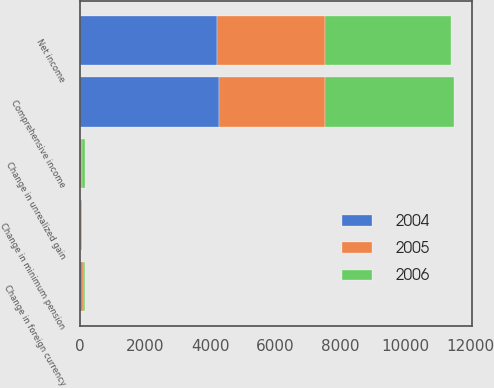Convert chart to OTSL. <chart><loc_0><loc_0><loc_500><loc_500><stacked_bar_chart><ecel><fcel>Net income<fcel>Change in foreign currency<fcel>Change in unrealized gain<fcel>Change in minimum pension<fcel>Comprehensive income<nl><fcel>2004<fcel>4202<fcel>54<fcel>15<fcel>16<fcel>4258<nl><fcel>2006<fcel>3870<fcel>36<fcel>112<fcel>14<fcel>3948<nl><fcel>2005<fcel>3333<fcel>71<fcel>43<fcel>18<fcel>3268<nl></chart> 